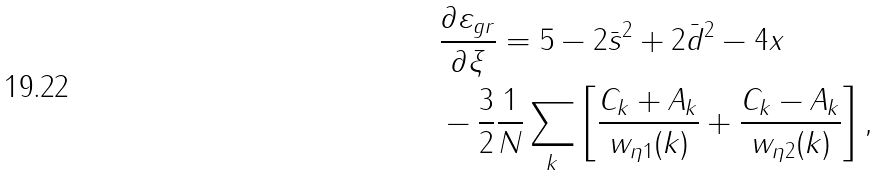<formula> <loc_0><loc_0><loc_500><loc_500>& \frac { \partial \varepsilon _ { g r } } { \partial \xi } = 5 - 2 \bar { s } ^ { 2 } + 2 \bar { d } ^ { 2 } - 4 x \\ & - \frac { 3 } { 2 } \frac { 1 } { N } \sum _ { k } \left [ \frac { C _ { k } + A _ { k } } { w _ { \eta 1 } ( k ) } + \frac { C _ { k } - A _ { k } } { w _ { \eta 2 } ( k ) } \right ] ,</formula> 